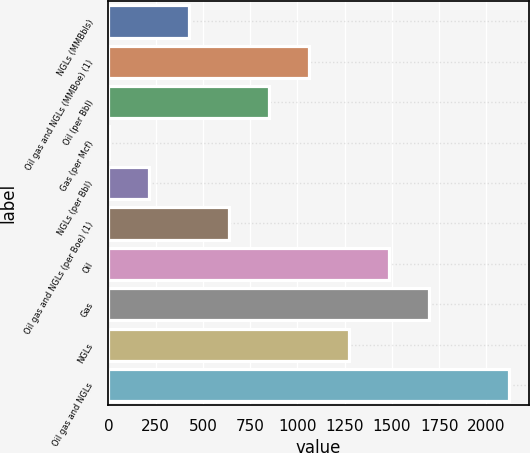Convert chart to OTSL. <chart><loc_0><loc_0><loc_500><loc_500><bar_chart><fcel>NGLs (MMBbls)<fcel>Oil gas and NGLs (MMBoe) (1)<fcel>Oil (per Bbl)<fcel>Gas (per Mcf)<fcel>NGLs (per Bbl)<fcel>Oil gas and NGLs (per Boe) (1)<fcel>Oil<fcel>Gas<fcel>NGLs<fcel>Oil gas and NGLs<nl><fcel>426.13<fcel>1060.96<fcel>849.35<fcel>2.91<fcel>214.52<fcel>637.74<fcel>1484.18<fcel>1695.79<fcel>1272.57<fcel>2119<nl></chart> 